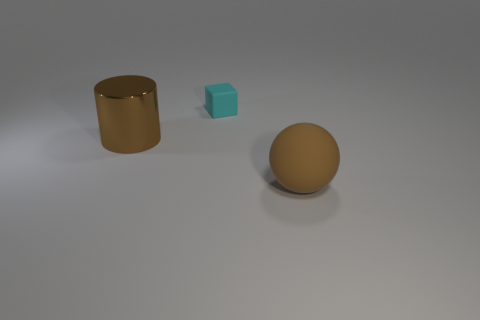The object that is made of the same material as the cyan block is what shape? The object sharing the same material as the cyan block appears to be the sphere, which exhibits a uniform texture and matte finish akin to the block. 